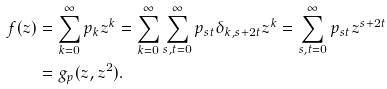Convert formula to latex. <formula><loc_0><loc_0><loc_500><loc_500>f ( z ) & = \sum _ { k = 0 } ^ { \infty } p _ { k } z ^ { k } = \sum _ { k = 0 } ^ { \infty } \sum _ { s , t = 0 } ^ { \infty } p _ { s t } \delta _ { k , s + 2 t } z ^ { k } = \sum _ { s , t = 0 } ^ { \infty } p _ { s t } z ^ { s + 2 t } \\ & = g _ { p } ( z , z ^ { 2 } ) .</formula> 